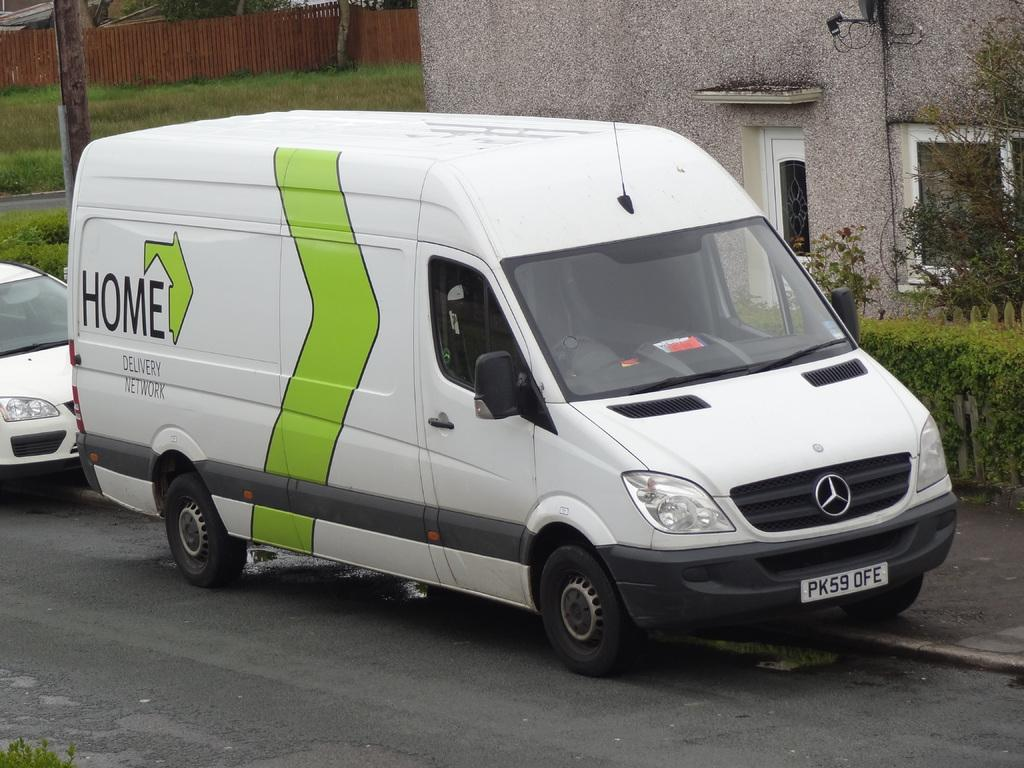<image>
Relay a brief, clear account of the picture shown. A white Mercedes van that says Home Delivery Network on it. 